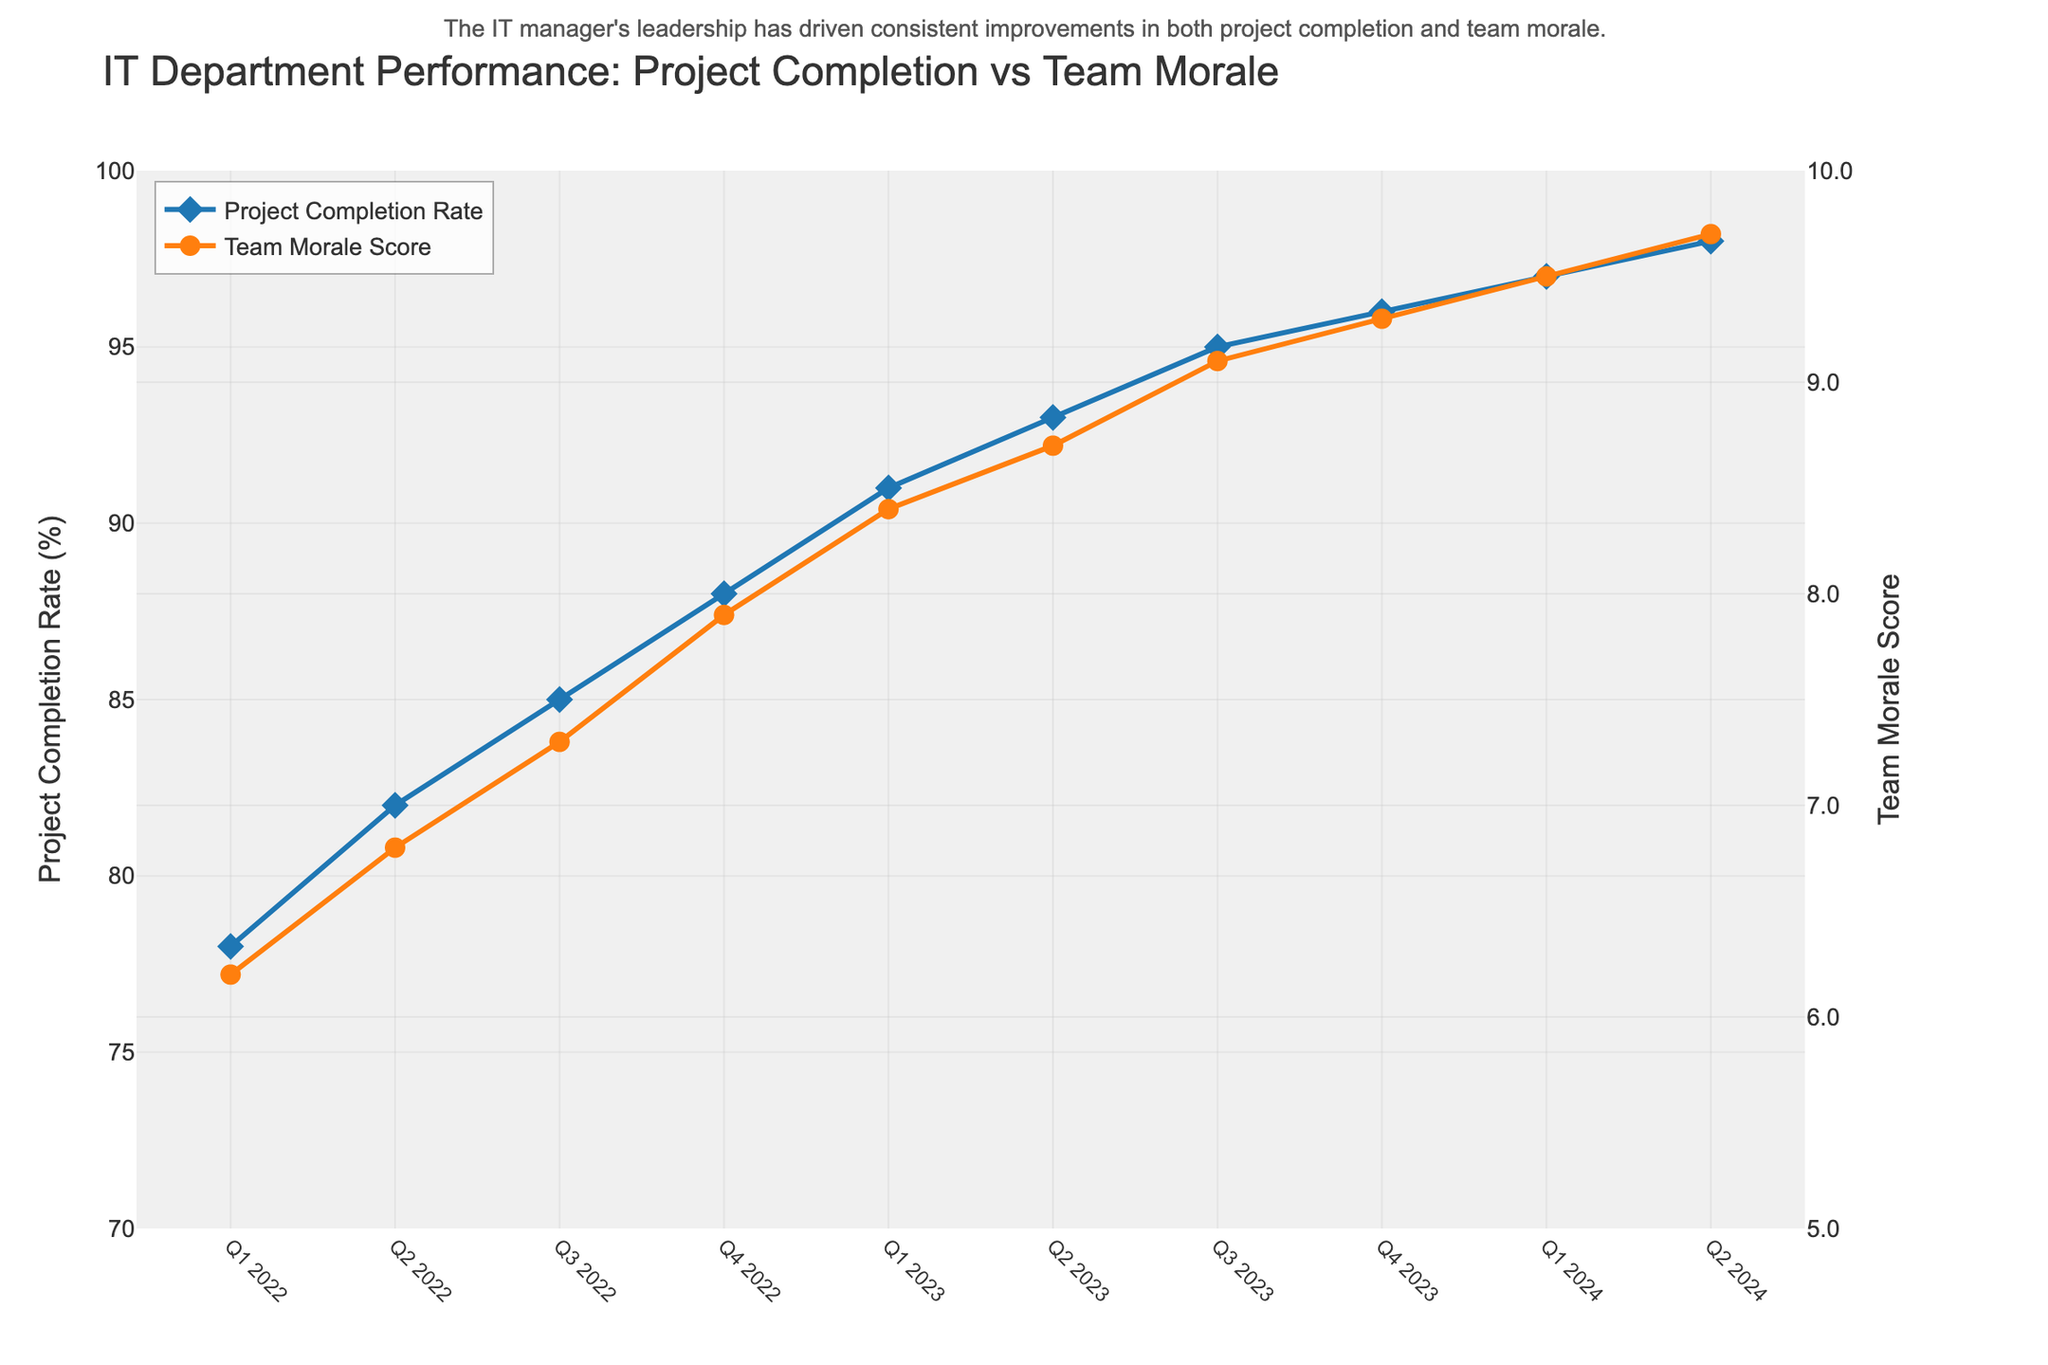What is the general trend of the Project Completion Rate from Q1 2022 to Q2 2024? By observing the line corresponding to the Project Completion Rate, we can see that it increases consistently from Q1 2022 to Q2 2024. Each subsequent quarter shows a higher completion rate than the previous one.
Answer: Increasing How does the Team Morale Score change from Q1 2022 to Q2 2024? By looking at the line representing the Team Morale Score, it is evident that the score continuously increases from Q1 2022 to Q2 2024. Every quarter registers a higher morale score.
Answer: Increasing Which quarter had the highest project completion rate and what was the rate? By examining the peak of the Project Completion Rate line, we can identify that Q2 2024 had the highest completion rate of 98%.
Answer: Q2 2024, 98% During which quarter did Team Morale Score reach 9.0 or higher for the first time? By tracing the Team Morale Score line, we observe that the score reaches 9.0 in Q3 2023 and continues to be higher thereafter.
Answer: Q3 2023 Compare the Project Completion Rate and Team Morale Score in Q1 2022 and Q1 2023. Which metric showed a greater change? The Project Completion Rate in Q1 2022 is 78%, and in Q1 2023 it's 91%, indicating a change of 13 percentage points. The Team Morale Score in Q1 2022 is 6.2, and in Q1 2023 it's 8.4, indicating a change of 2.2 points. Hence, the Project Completion Rate showed a greater change.
Answer: Project Completion Rate Between Q2 2023 and Q4 2023, by how much did the Team Morale Score increase? The Team Morale Score in Q2 2023 is 8.7, and in Q4 2023 it's 9.3. Subtracting the former from the latter, we get an increase of 0.6 points.
Answer: 0.6 points How did the Project Completion Rate in Q2 2024 compare to Q4 2023? The Project Completion Rate in Q2 2024 was 98%, while in Q4 2023 it was 96%. Therefore, Q2 2024 had a higher completion rate by 2 percentage points.
Answer: Higher by 2 percentage points Looking at the overall data, is there a correlation between Project Completion Rate and Team Morale Score? By observing the overall trends of both the Project Completion Rate and Team Morale Score, which both continuously increase, we can infer that there is a strong positive correlation between the two metrics.
Answer: Yes What specific annotation is mentioned regarding the IT manager's influence on the trends? The annotation states, “The IT manager's leadership has driven consistent improvements in both project completion and team morale.” This highlights the positive impact of the IT manager's leadership on both metrics.
Answer: The IT manager's leadership has driven consistent improvements in both project completion and team morale What is the difference in Project Completion Rates between the lowest and highest quarters? The lowest Project Completion Rate is in Q1 2022 at 78%, and the highest is in Q2 2024 at 98%. The difference is 98% - 78% = 20%.
Answer: 20% 